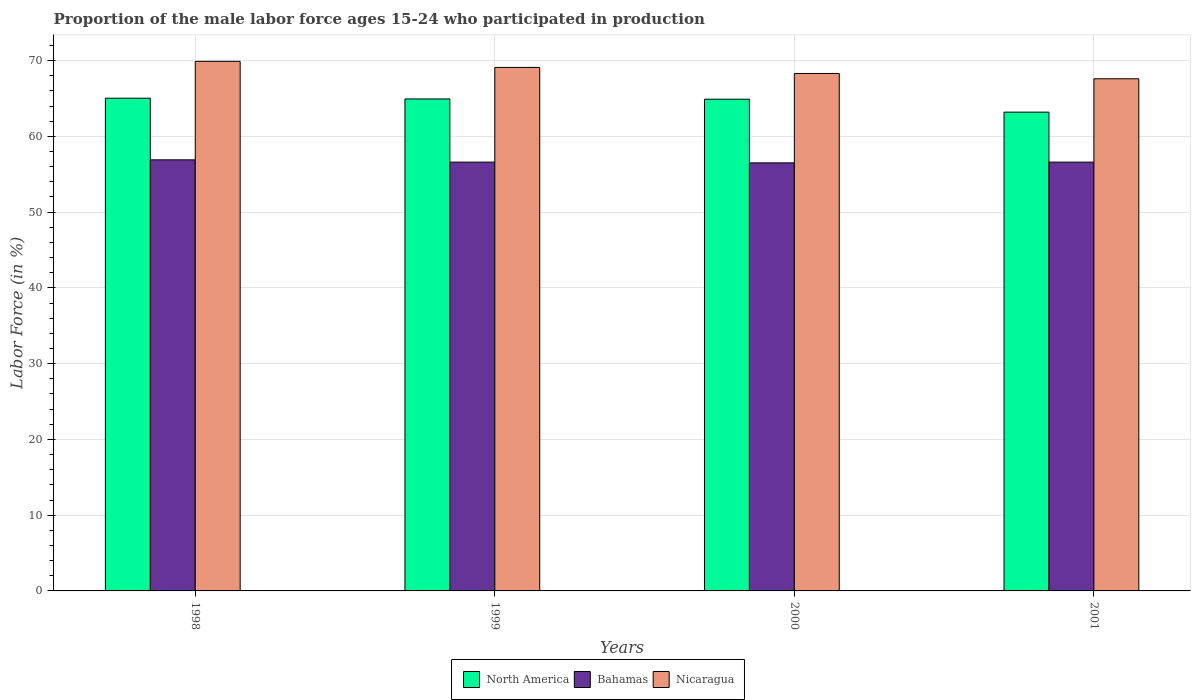How many different coloured bars are there?
Offer a very short reply. 3. Are the number of bars per tick equal to the number of legend labels?
Offer a very short reply. Yes. Are the number of bars on each tick of the X-axis equal?
Your response must be concise. Yes. How many bars are there on the 2nd tick from the left?
Your response must be concise. 3. How many bars are there on the 2nd tick from the right?
Your answer should be compact. 3. In how many cases, is the number of bars for a given year not equal to the number of legend labels?
Your response must be concise. 0. What is the proportion of the male labor force who participated in production in Bahamas in 1998?
Your response must be concise. 56.9. Across all years, what is the maximum proportion of the male labor force who participated in production in Nicaragua?
Give a very brief answer. 69.9. Across all years, what is the minimum proportion of the male labor force who participated in production in Bahamas?
Keep it short and to the point. 56.5. In which year was the proportion of the male labor force who participated in production in Nicaragua minimum?
Your response must be concise. 2001. What is the total proportion of the male labor force who participated in production in Bahamas in the graph?
Offer a terse response. 226.6. What is the difference between the proportion of the male labor force who participated in production in North America in 1999 and that in 2000?
Your response must be concise. 0.03. What is the difference between the proportion of the male labor force who participated in production in North America in 2000 and the proportion of the male labor force who participated in production in Nicaragua in 2001?
Your answer should be very brief. -2.7. What is the average proportion of the male labor force who participated in production in Bahamas per year?
Offer a very short reply. 56.65. In the year 2001, what is the difference between the proportion of the male labor force who participated in production in Nicaragua and proportion of the male labor force who participated in production in North America?
Provide a succinct answer. 4.41. In how many years, is the proportion of the male labor force who participated in production in Bahamas greater than 30 %?
Give a very brief answer. 4. What is the ratio of the proportion of the male labor force who participated in production in Nicaragua in 1998 to that in 2000?
Give a very brief answer. 1.02. Is the proportion of the male labor force who participated in production in North America in 1998 less than that in 2000?
Offer a terse response. No. Is the difference between the proportion of the male labor force who participated in production in Nicaragua in 1998 and 2000 greater than the difference between the proportion of the male labor force who participated in production in North America in 1998 and 2000?
Your response must be concise. Yes. What is the difference between the highest and the second highest proportion of the male labor force who participated in production in North America?
Keep it short and to the point. 0.1. What is the difference between the highest and the lowest proportion of the male labor force who participated in production in North America?
Your answer should be very brief. 1.84. Is the sum of the proportion of the male labor force who participated in production in North America in 1999 and 2001 greater than the maximum proportion of the male labor force who participated in production in Nicaragua across all years?
Provide a short and direct response. Yes. What does the 1st bar from the left in 2000 represents?
Your answer should be compact. North America. What does the 2nd bar from the right in 2001 represents?
Make the answer very short. Bahamas. Is it the case that in every year, the sum of the proportion of the male labor force who participated in production in North America and proportion of the male labor force who participated in production in Nicaragua is greater than the proportion of the male labor force who participated in production in Bahamas?
Give a very brief answer. Yes. How many years are there in the graph?
Keep it short and to the point. 4. What is the difference between two consecutive major ticks on the Y-axis?
Keep it short and to the point. 10. Does the graph contain any zero values?
Your answer should be very brief. No. Does the graph contain grids?
Your answer should be compact. Yes. What is the title of the graph?
Your answer should be compact. Proportion of the male labor force ages 15-24 who participated in production. Does "Turkmenistan" appear as one of the legend labels in the graph?
Provide a succinct answer. No. What is the label or title of the Y-axis?
Provide a short and direct response. Labor Force (in %). What is the Labor Force (in %) in North America in 1998?
Your response must be concise. 65.04. What is the Labor Force (in %) of Bahamas in 1998?
Your response must be concise. 56.9. What is the Labor Force (in %) in Nicaragua in 1998?
Provide a succinct answer. 69.9. What is the Labor Force (in %) in North America in 1999?
Give a very brief answer. 64.94. What is the Labor Force (in %) of Bahamas in 1999?
Make the answer very short. 56.6. What is the Labor Force (in %) in Nicaragua in 1999?
Provide a short and direct response. 69.1. What is the Labor Force (in %) in North America in 2000?
Offer a terse response. 64.9. What is the Labor Force (in %) in Bahamas in 2000?
Provide a short and direct response. 56.5. What is the Labor Force (in %) in Nicaragua in 2000?
Provide a succinct answer. 68.3. What is the Labor Force (in %) in North America in 2001?
Make the answer very short. 63.19. What is the Labor Force (in %) in Bahamas in 2001?
Offer a terse response. 56.6. What is the Labor Force (in %) of Nicaragua in 2001?
Offer a terse response. 67.6. Across all years, what is the maximum Labor Force (in %) of North America?
Offer a very short reply. 65.04. Across all years, what is the maximum Labor Force (in %) of Bahamas?
Give a very brief answer. 56.9. Across all years, what is the maximum Labor Force (in %) in Nicaragua?
Provide a short and direct response. 69.9. Across all years, what is the minimum Labor Force (in %) in North America?
Offer a very short reply. 63.19. Across all years, what is the minimum Labor Force (in %) in Bahamas?
Ensure brevity in your answer.  56.5. Across all years, what is the minimum Labor Force (in %) in Nicaragua?
Offer a very short reply. 67.6. What is the total Labor Force (in %) of North America in the graph?
Your response must be concise. 258.07. What is the total Labor Force (in %) in Bahamas in the graph?
Offer a very short reply. 226.6. What is the total Labor Force (in %) in Nicaragua in the graph?
Provide a succinct answer. 274.9. What is the difference between the Labor Force (in %) of North America in 1998 and that in 1999?
Your response must be concise. 0.1. What is the difference between the Labor Force (in %) of Bahamas in 1998 and that in 1999?
Your answer should be compact. 0.3. What is the difference between the Labor Force (in %) of North America in 1998 and that in 2000?
Offer a very short reply. 0.13. What is the difference between the Labor Force (in %) of Nicaragua in 1998 and that in 2000?
Provide a short and direct response. 1.6. What is the difference between the Labor Force (in %) of North America in 1998 and that in 2001?
Provide a succinct answer. 1.84. What is the difference between the Labor Force (in %) of Nicaragua in 1998 and that in 2001?
Make the answer very short. 2.3. What is the difference between the Labor Force (in %) in North America in 1999 and that in 2000?
Your response must be concise. 0.03. What is the difference between the Labor Force (in %) of Bahamas in 1999 and that in 2000?
Provide a succinct answer. 0.1. What is the difference between the Labor Force (in %) in Nicaragua in 1999 and that in 2000?
Provide a succinct answer. 0.8. What is the difference between the Labor Force (in %) of North America in 1999 and that in 2001?
Provide a short and direct response. 1.74. What is the difference between the Labor Force (in %) of North America in 2000 and that in 2001?
Offer a terse response. 1.71. What is the difference between the Labor Force (in %) of Bahamas in 2000 and that in 2001?
Keep it short and to the point. -0.1. What is the difference between the Labor Force (in %) in North America in 1998 and the Labor Force (in %) in Bahamas in 1999?
Offer a very short reply. 8.44. What is the difference between the Labor Force (in %) of North America in 1998 and the Labor Force (in %) of Nicaragua in 1999?
Make the answer very short. -4.06. What is the difference between the Labor Force (in %) in North America in 1998 and the Labor Force (in %) in Bahamas in 2000?
Your response must be concise. 8.54. What is the difference between the Labor Force (in %) in North America in 1998 and the Labor Force (in %) in Nicaragua in 2000?
Make the answer very short. -3.26. What is the difference between the Labor Force (in %) in Bahamas in 1998 and the Labor Force (in %) in Nicaragua in 2000?
Your response must be concise. -11.4. What is the difference between the Labor Force (in %) of North America in 1998 and the Labor Force (in %) of Bahamas in 2001?
Keep it short and to the point. 8.44. What is the difference between the Labor Force (in %) in North America in 1998 and the Labor Force (in %) in Nicaragua in 2001?
Make the answer very short. -2.56. What is the difference between the Labor Force (in %) of Bahamas in 1998 and the Labor Force (in %) of Nicaragua in 2001?
Your response must be concise. -10.7. What is the difference between the Labor Force (in %) in North America in 1999 and the Labor Force (in %) in Bahamas in 2000?
Offer a very short reply. 8.44. What is the difference between the Labor Force (in %) in North America in 1999 and the Labor Force (in %) in Nicaragua in 2000?
Keep it short and to the point. -3.36. What is the difference between the Labor Force (in %) of Bahamas in 1999 and the Labor Force (in %) of Nicaragua in 2000?
Your response must be concise. -11.7. What is the difference between the Labor Force (in %) in North America in 1999 and the Labor Force (in %) in Bahamas in 2001?
Provide a short and direct response. 8.34. What is the difference between the Labor Force (in %) in North America in 1999 and the Labor Force (in %) in Nicaragua in 2001?
Offer a terse response. -2.66. What is the difference between the Labor Force (in %) of North America in 2000 and the Labor Force (in %) of Bahamas in 2001?
Your answer should be compact. 8.3. What is the difference between the Labor Force (in %) in North America in 2000 and the Labor Force (in %) in Nicaragua in 2001?
Your answer should be compact. -2.7. What is the average Labor Force (in %) of North America per year?
Your answer should be compact. 64.52. What is the average Labor Force (in %) in Bahamas per year?
Your answer should be compact. 56.65. What is the average Labor Force (in %) in Nicaragua per year?
Ensure brevity in your answer.  68.72. In the year 1998, what is the difference between the Labor Force (in %) of North America and Labor Force (in %) of Bahamas?
Ensure brevity in your answer.  8.14. In the year 1998, what is the difference between the Labor Force (in %) in North America and Labor Force (in %) in Nicaragua?
Keep it short and to the point. -4.86. In the year 1999, what is the difference between the Labor Force (in %) in North America and Labor Force (in %) in Bahamas?
Give a very brief answer. 8.34. In the year 1999, what is the difference between the Labor Force (in %) of North America and Labor Force (in %) of Nicaragua?
Give a very brief answer. -4.16. In the year 1999, what is the difference between the Labor Force (in %) of Bahamas and Labor Force (in %) of Nicaragua?
Your answer should be very brief. -12.5. In the year 2000, what is the difference between the Labor Force (in %) in North America and Labor Force (in %) in Bahamas?
Your answer should be compact. 8.4. In the year 2000, what is the difference between the Labor Force (in %) of North America and Labor Force (in %) of Nicaragua?
Provide a short and direct response. -3.4. In the year 2001, what is the difference between the Labor Force (in %) in North America and Labor Force (in %) in Bahamas?
Your answer should be very brief. 6.59. In the year 2001, what is the difference between the Labor Force (in %) in North America and Labor Force (in %) in Nicaragua?
Provide a succinct answer. -4.41. What is the ratio of the Labor Force (in %) of North America in 1998 to that in 1999?
Your response must be concise. 1. What is the ratio of the Labor Force (in %) of Bahamas in 1998 to that in 1999?
Your answer should be very brief. 1.01. What is the ratio of the Labor Force (in %) in Nicaragua in 1998 to that in 1999?
Make the answer very short. 1.01. What is the ratio of the Labor Force (in %) of North America in 1998 to that in 2000?
Your answer should be compact. 1. What is the ratio of the Labor Force (in %) of Bahamas in 1998 to that in 2000?
Make the answer very short. 1.01. What is the ratio of the Labor Force (in %) of Nicaragua in 1998 to that in 2000?
Ensure brevity in your answer.  1.02. What is the ratio of the Labor Force (in %) of North America in 1998 to that in 2001?
Offer a terse response. 1.03. What is the ratio of the Labor Force (in %) of Bahamas in 1998 to that in 2001?
Your answer should be very brief. 1.01. What is the ratio of the Labor Force (in %) of Nicaragua in 1998 to that in 2001?
Provide a succinct answer. 1.03. What is the ratio of the Labor Force (in %) in Bahamas in 1999 to that in 2000?
Offer a very short reply. 1. What is the ratio of the Labor Force (in %) of Nicaragua in 1999 to that in 2000?
Keep it short and to the point. 1.01. What is the ratio of the Labor Force (in %) of North America in 1999 to that in 2001?
Give a very brief answer. 1.03. What is the ratio of the Labor Force (in %) of Nicaragua in 1999 to that in 2001?
Your response must be concise. 1.02. What is the ratio of the Labor Force (in %) in North America in 2000 to that in 2001?
Provide a succinct answer. 1.03. What is the ratio of the Labor Force (in %) in Bahamas in 2000 to that in 2001?
Ensure brevity in your answer.  1. What is the ratio of the Labor Force (in %) in Nicaragua in 2000 to that in 2001?
Your response must be concise. 1.01. What is the difference between the highest and the second highest Labor Force (in %) of North America?
Offer a very short reply. 0.1. What is the difference between the highest and the second highest Labor Force (in %) in Bahamas?
Keep it short and to the point. 0.3. What is the difference between the highest and the second highest Labor Force (in %) in Nicaragua?
Provide a short and direct response. 0.8. What is the difference between the highest and the lowest Labor Force (in %) of North America?
Provide a succinct answer. 1.84. What is the difference between the highest and the lowest Labor Force (in %) in Nicaragua?
Give a very brief answer. 2.3. 